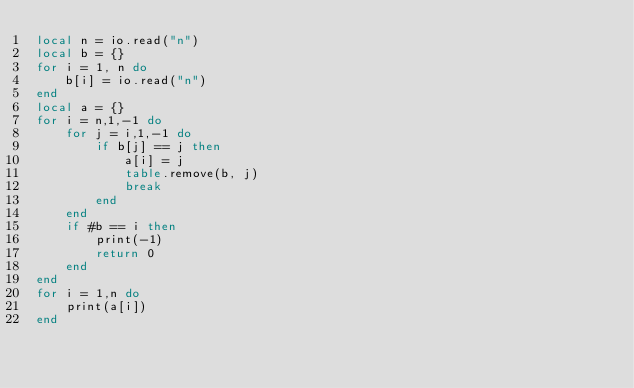<code> <loc_0><loc_0><loc_500><loc_500><_Lua_>local n = io.read("n")
local b = {}
for i = 1, n do
    b[i] = io.read("n")
end
local a = {}
for i = n,1,-1 do
    for j = i,1,-1 do
        if b[j] == j then
            a[i] = j
            table.remove(b, j)
            break
        end
    end
    if #b == i then
        print(-1)
        return 0
    end
end
for i = 1,n do
    print(a[i])
end</code> 